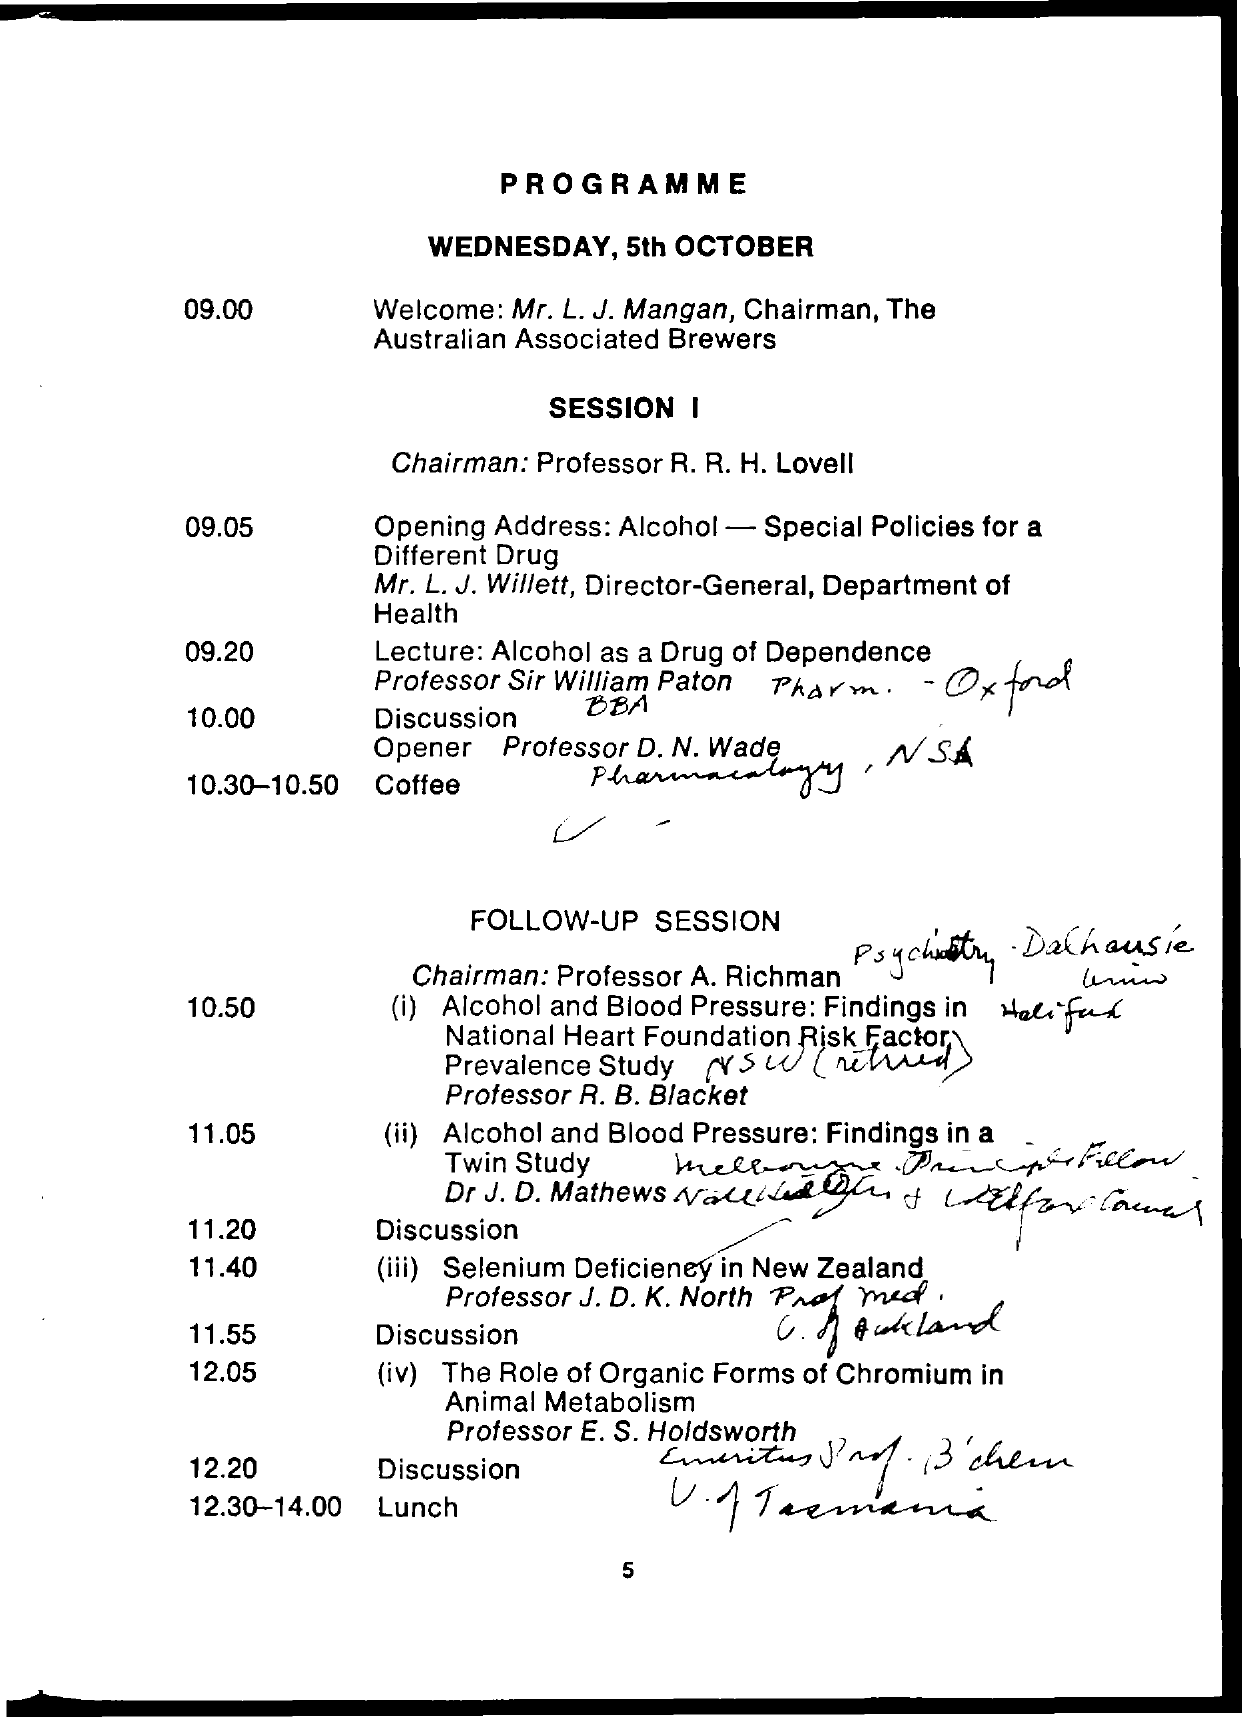Give some essential details in this illustration. When is the lunch time? From 12:30 to 14:00. The date mentioned is Wednesday, October 5th. The coffee time is scheduled for 10:30-10:50 on Monday. 